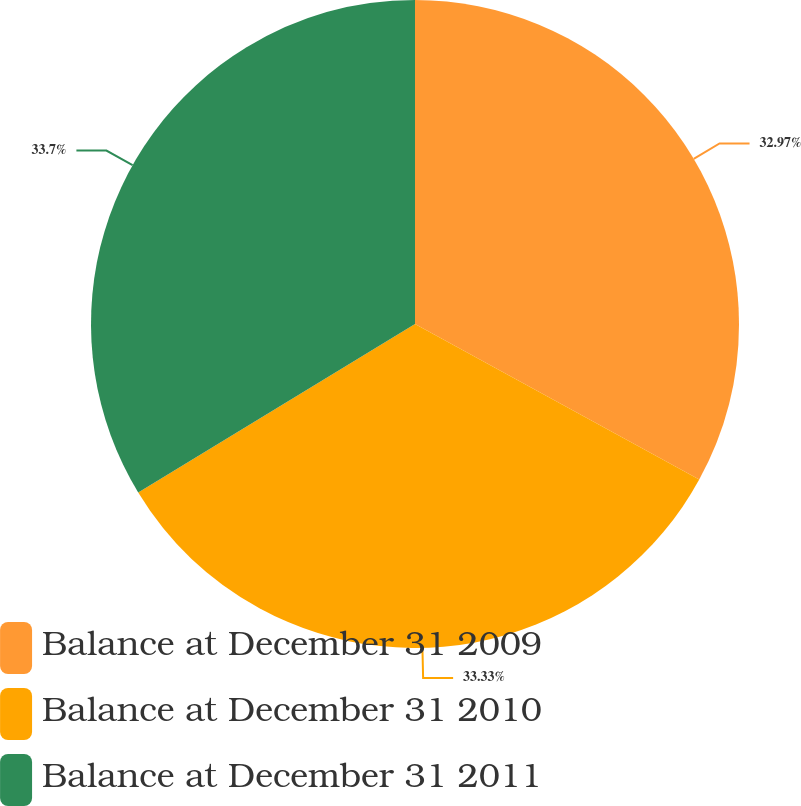Convert chart to OTSL. <chart><loc_0><loc_0><loc_500><loc_500><pie_chart><fcel>Balance at December 31 2009<fcel>Balance at December 31 2010<fcel>Balance at December 31 2011<nl><fcel>32.97%<fcel>33.33%<fcel>33.7%<nl></chart> 